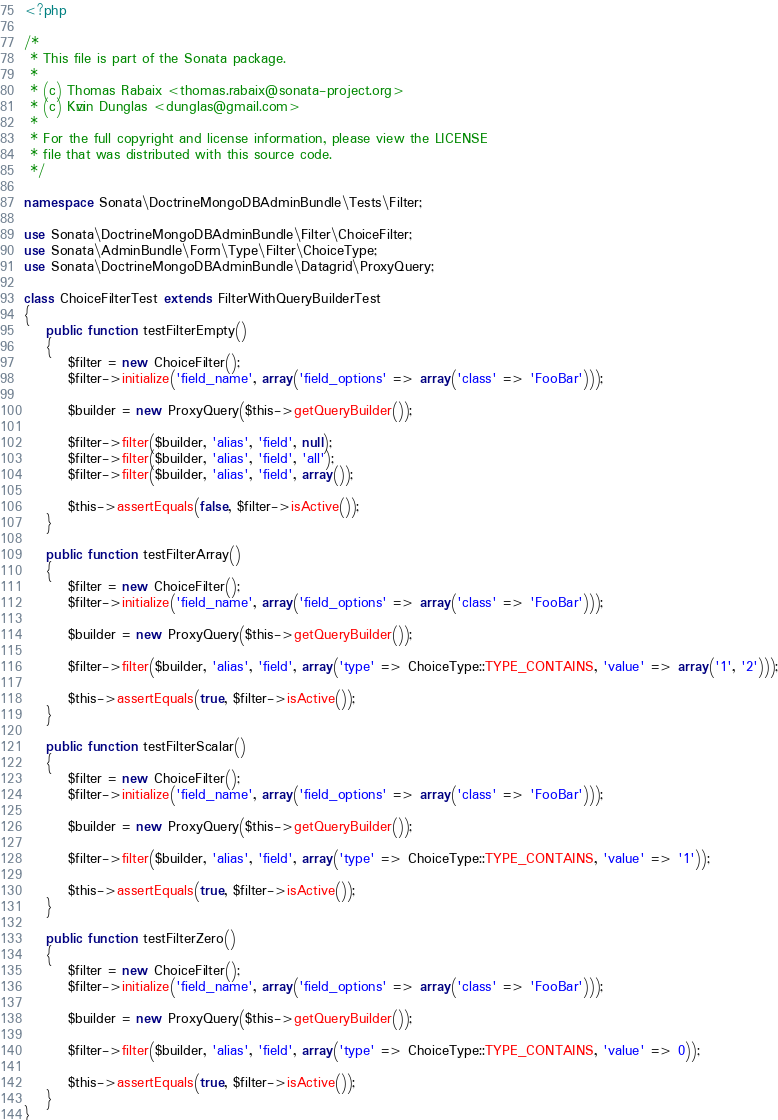Convert code to text. <code><loc_0><loc_0><loc_500><loc_500><_PHP_><?php

/*
 * This file is part of the Sonata package.
 *
 * (c) Thomas Rabaix <thomas.rabaix@sonata-project.org>
 * (c) Kévin Dunglas <dunglas@gmail.com>
 *
 * For the full copyright and license information, please view the LICENSE
 * file that was distributed with this source code.
 */

namespace Sonata\DoctrineMongoDBAdminBundle\Tests\Filter;

use Sonata\DoctrineMongoDBAdminBundle\Filter\ChoiceFilter;
use Sonata\AdminBundle\Form\Type\Filter\ChoiceType;
use Sonata\DoctrineMongoDBAdminBundle\Datagrid\ProxyQuery;

class ChoiceFilterTest extends FilterWithQueryBuilderTest
{
    public function testFilterEmpty()
    {
        $filter = new ChoiceFilter();
        $filter->initialize('field_name', array('field_options' => array('class' => 'FooBar')));

        $builder = new ProxyQuery($this->getQueryBuilder());

        $filter->filter($builder, 'alias', 'field', null);
        $filter->filter($builder, 'alias', 'field', 'all');
        $filter->filter($builder, 'alias', 'field', array());

        $this->assertEquals(false, $filter->isActive());
    }

    public function testFilterArray()
    {
        $filter = new ChoiceFilter();
        $filter->initialize('field_name', array('field_options' => array('class' => 'FooBar')));

        $builder = new ProxyQuery($this->getQueryBuilder());

        $filter->filter($builder, 'alias', 'field', array('type' => ChoiceType::TYPE_CONTAINS, 'value' => array('1', '2')));

        $this->assertEquals(true, $filter->isActive());
    }

    public function testFilterScalar()
    {
        $filter = new ChoiceFilter();
        $filter->initialize('field_name', array('field_options' => array('class' => 'FooBar')));

        $builder = new ProxyQuery($this->getQueryBuilder());

        $filter->filter($builder, 'alias', 'field', array('type' => ChoiceType::TYPE_CONTAINS, 'value' => '1'));

        $this->assertEquals(true, $filter->isActive());
    }

    public function testFilterZero()
    {
        $filter = new ChoiceFilter();
        $filter->initialize('field_name', array('field_options' => array('class' => 'FooBar')));

        $builder = new ProxyQuery($this->getQueryBuilder());

        $filter->filter($builder, 'alias', 'field', array('type' => ChoiceType::TYPE_CONTAINS, 'value' => 0));

        $this->assertEquals(true, $filter->isActive());
    }
}
</code> 